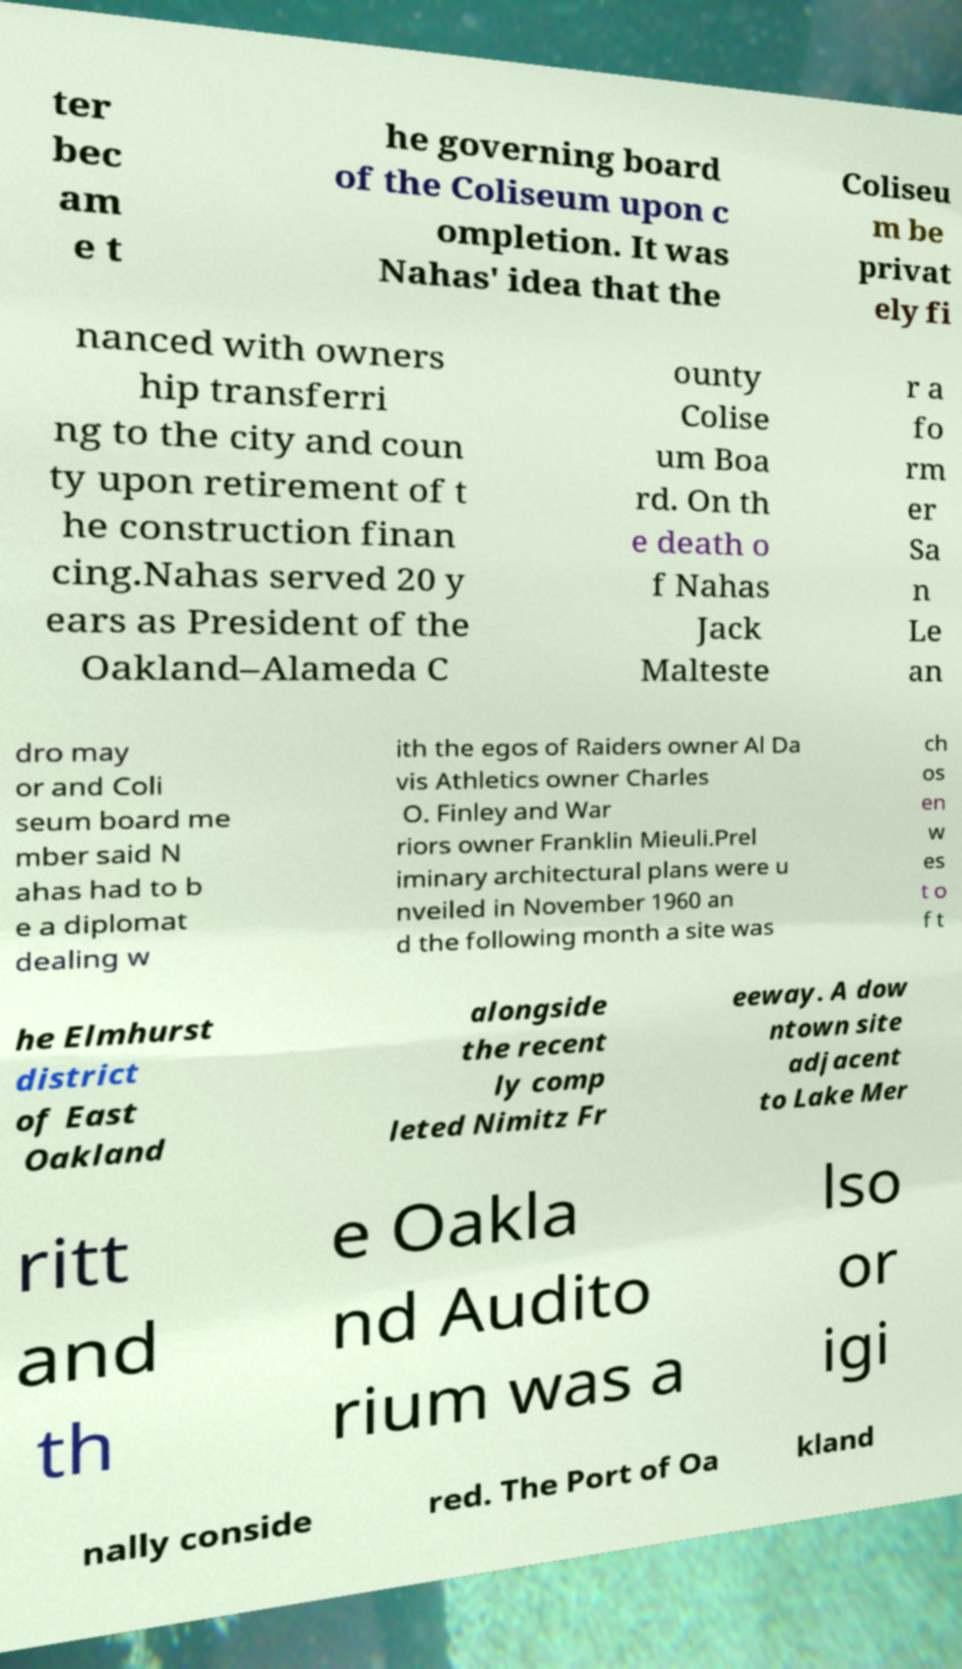Please read and relay the text visible in this image. What does it say? ter bec am e t he governing board of the Coliseum upon c ompletion. It was Nahas' idea that the Coliseu m be privat ely fi nanced with owners hip transferri ng to the city and coun ty upon retirement of t he construction finan cing.Nahas served 20 y ears as President of the Oakland–Alameda C ounty Colise um Boa rd. On th e death o f Nahas Jack Malteste r a fo rm er Sa n Le an dro may or and Coli seum board me mber said N ahas had to b e a diplomat dealing w ith the egos of Raiders owner Al Da vis Athletics owner Charles O. Finley and War riors owner Franklin Mieuli.Prel iminary architectural plans were u nveiled in November 1960 an d the following month a site was ch os en w es t o f t he Elmhurst district of East Oakland alongside the recent ly comp leted Nimitz Fr eeway. A dow ntown site adjacent to Lake Mer ritt and th e Oakla nd Audito rium was a lso or igi nally conside red. The Port of Oa kland 